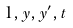Convert formula to latex. <formula><loc_0><loc_0><loc_500><loc_500>1 , y , y ^ { \prime } , t</formula> 